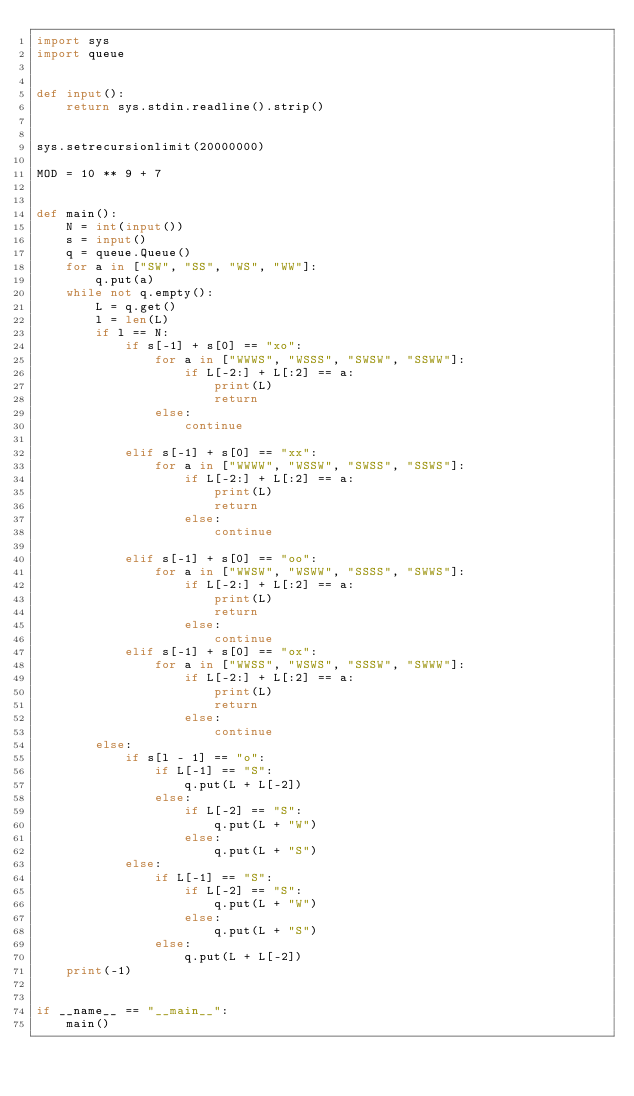Convert code to text. <code><loc_0><loc_0><loc_500><loc_500><_Python_>import sys
import queue


def input():
    return sys.stdin.readline().strip()


sys.setrecursionlimit(20000000)

MOD = 10 ** 9 + 7


def main():
    N = int(input())
    s = input()
    q = queue.Queue()
    for a in ["SW", "SS", "WS", "WW"]:
        q.put(a)
    while not q.empty():
        L = q.get()
        l = len(L)
        if l == N:
            if s[-1] + s[0] == "xo":
                for a in ["WWWS", "WSSS", "SWSW", "SSWW"]:
                    if L[-2:] + L[:2] == a:
                        print(L)
                        return
                else:
                    continue

            elif s[-1] + s[0] == "xx":
                for a in ["WWWW", "WSSW", "SWSS", "SSWS"]:
                    if L[-2:] + L[:2] == a:
                        print(L)
                        return
                    else:
                        continue

            elif s[-1] + s[0] == "oo":
                for a in ["WWSW", "WSWW", "SSSS", "SWWS"]:
                    if L[-2:] + L[:2] == a:
                        print(L)
                        return
                    else:
                        continue
            elif s[-1] + s[0] == "ox":
                for a in ["WWSS", "WSWS", "SSSW", "SWWW"]:
                    if L[-2:] + L[:2] == a:
                        print(L)
                        return
                    else:
                        continue
        else:
            if s[l - 1] == "o":
                if L[-1] == "S":
                    q.put(L + L[-2])
                else:
                    if L[-2] == "S":
                        q.put(L + "W")
                    else:
                        q.put(L + "S")
            else:
                if L[-1] == "S":
                    if L[-2] == "S":
                        q.put(L + "W")
                    else:
                        q.put(L + "S")
                else:
                    q.put(L + L[-2])
    print(-1)


if __name__ == "__main__":
    main()
</code> 